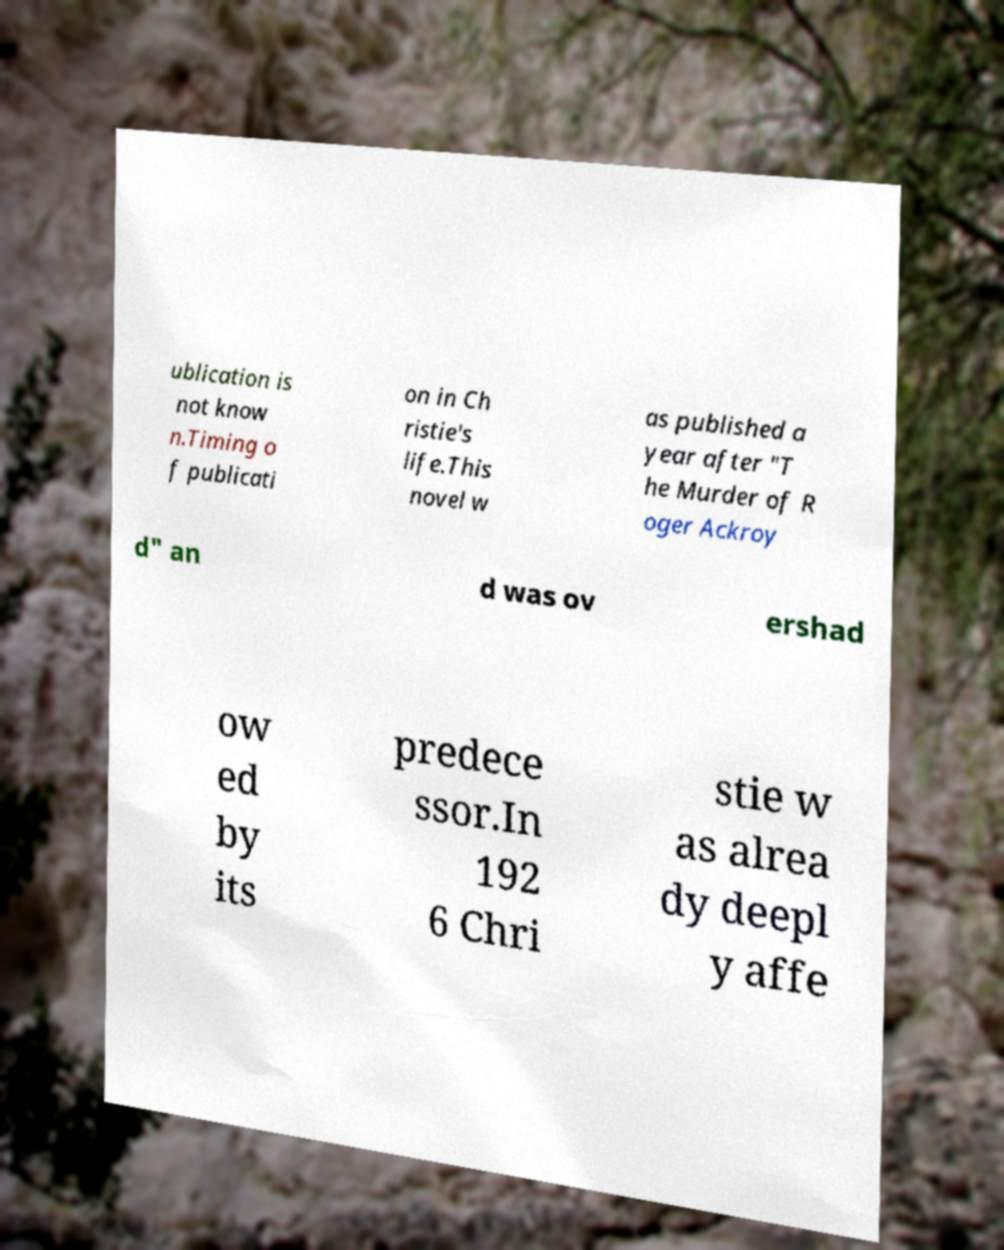Could you assist in decoding the text presented in this image and type it out clearly? ublication is not know n.Timing o f publicati on in Ch ristie's life.This novel w as published a year after "T he Murder of R oger Ackroy d" an d was ov ershad ow ed by its predece ssor.In 192 6 Chri stie w as alrea dy deepl y affe 